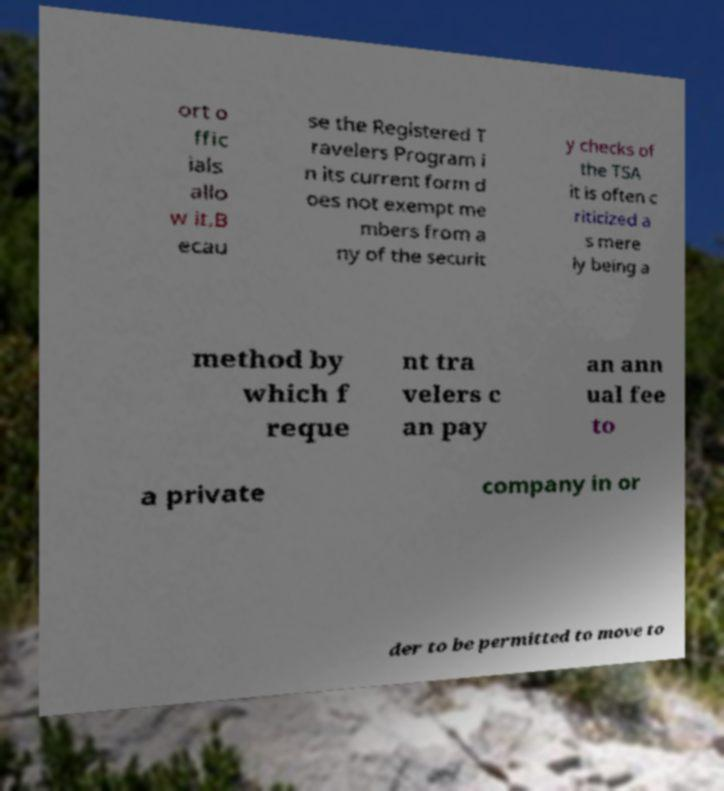Please identify and transcribe the text found in this image. ort o ffic ials allo w it.B ecau se the Registered T ravelers Program i n its current form d oes not exempt me mbers from a ny of the securit y checks of the TSA it is often c riticized a s mere ly being a method by which f reque nt tra velers c an pay an ann ual fee to a private company in or der to be permitted to move to 